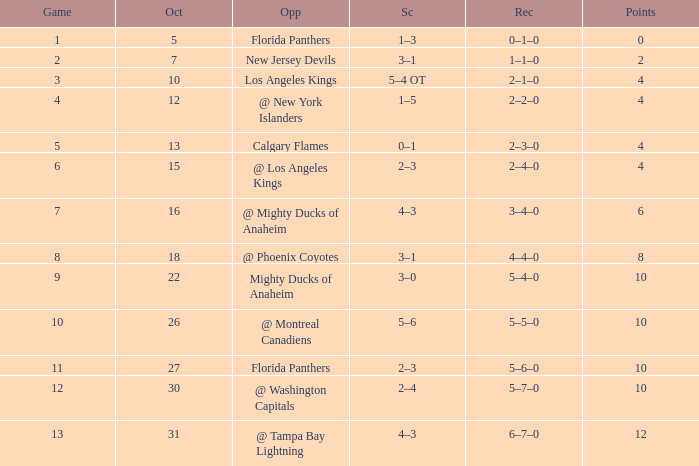What team has a score of 2 3–1. Would you be able to parse every entry in this table? {'header': ['Game', 'Oct', 'Opp', 'Sc', 'Rec', 'Points'], 'rows': [['1', '5', 'Florida Panthers', '1–3', '0–1–0', '0'], ['2', '7', 'New Jersey Devils', '3–1', '1–1–0', '2'], ['3', '10', 'Los Angeles Kings', '5–4 OT', '2–1–0', '4'], ['4', '12', '@ New York Islanders', '1–5', '2–2–0', '4'], ['5', '13', 'Calgary Flames', '0–1', '2–3–0', '4'], ['6', '15', '@ Los Angeles Kings', '2–3', '2–4–0', '4'], ['7', '16', '@ Mighty Ducks of Anaheim', '4–3', '3–4–0', '6'], ['8', '18', '@ Phoenix Coyotes', '3–1', '4–4–0', '8'], ['9', '22', 'Mighty Ducks of Anaheim', '3–0', '5–4–0', '10'], ['10', '26', '@ Montreal Canadiens', '5–6', '5–5–0', '10'], ['11', '27', 'Florida Panthers', '2–3', '5–6–0', '10'], ['12', '30', '@ Washington Capitals', '2–4', '5–7–0', '10'], ['13', '31', '@ Tampa Bay Lightning', '4–3', '6–7–0', '12']]} 